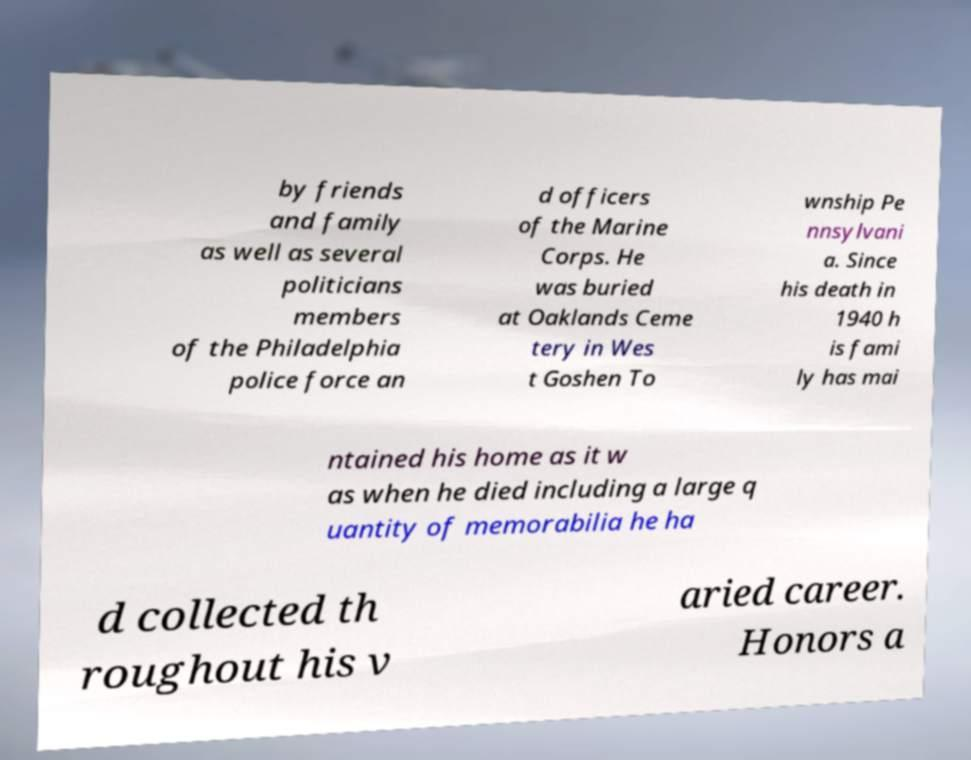I need the written content from this picture converted into text. Can you do that? by friends and family as well as several politicians members of the Philadelphia police force an d officers of the Marine Corps. He was buried at Oaklands Ceme tery in Wes t Goshen To wnship Pe nnsylvani a. Since his death in 1940 h is fami ly has mai ntained his home as it w as when he died including a large q uantity of memorabilia he ha d collected th roughout his v aried career. Honors a 